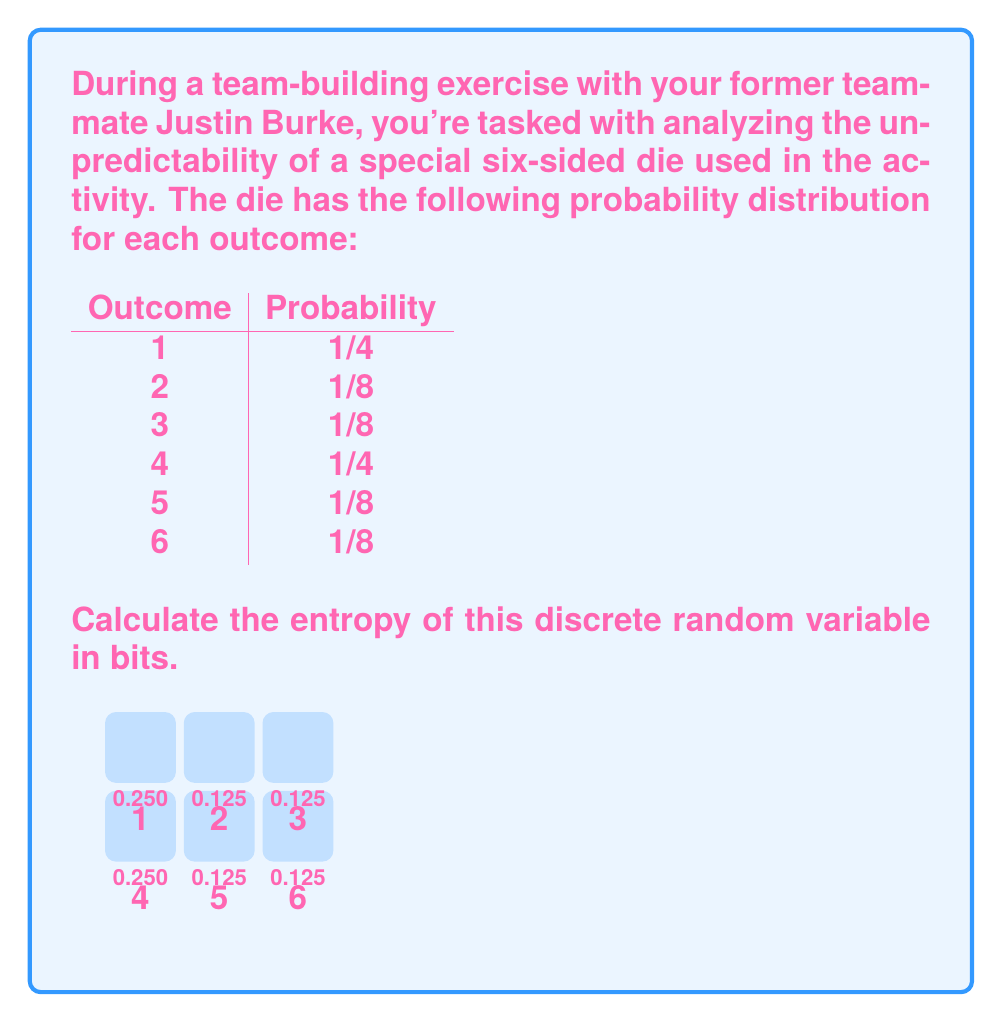Show me your answer to this math problem. To calculate the entropy of a discrete random variable, we use the formula:

$$H(X) = -\sum_{i=1}^n p(x_i) \log_2 p(x_i)$$

where $p(x_i)$ is the probability of each outcome.

Let's calculate each term:

1. For outcome 1: $-\frac{1}{4} \log_2 \frac{1}{4} = 0.5$
2. For outcome 2: $-\frac{1}{8} \log_2 \frac{1}{8} = 0.375$
3. For outcome 3: $-\frac{1}{8} \log_2 \frac{1}{8} = 0.375$
4. For outcome 4: $-\frac{1}{4} \log_2 \frac{1}{4} = 0.5$
5. For outcome 5: $-\frac{1}{8} \log_2 \frac{1}{8} = 0.375$
6. For outcome 6: $-\frac{1}{8} \log_2 \frac{1}{8} = 0.375$

Now, we sum all these terms:

$$H(X) = 0.5 + 0.375 + 0.375 + 0.5 + 0.375 + 0.375 = 2.5$$

Therefore, the entropy of this discrete random variable is 2.5 bits.
Answer: 2.5 bits 